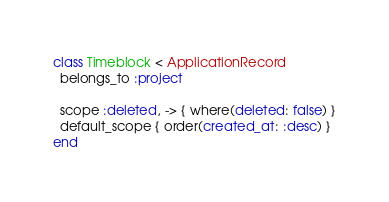Convert code to text. <code><loc_0><loc_0><loc_500><loc_500><_Ruby_>class Timeblock < ApplicationRecord
  belongs_to :project

  scope :deleted, -> { where(deleted: false) }
  default_scope { order(created_at: :desc) }
end
</code> 